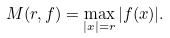<formula> <loc_0><loc_0><loc_500><loc_500>M ( r , f ) = \max _ { | x | = r } | f ( x ) | .</formula> 